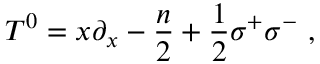<formula> <loc_0><loc_0><loc_500><loc_500>T ^ { 0 } = x \partial _ { x } - { \frac { n } { 2 } } + { \frac { 1 } { 2 } } \sigma ^ { + } \sigma ^ { - } \ ,</formula> 